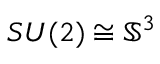<formula> <loc_0><loc_0><loc_500><loc_500>S U ( 2 ) \cong \mathbb { S } ^ { 3 }</formula> 